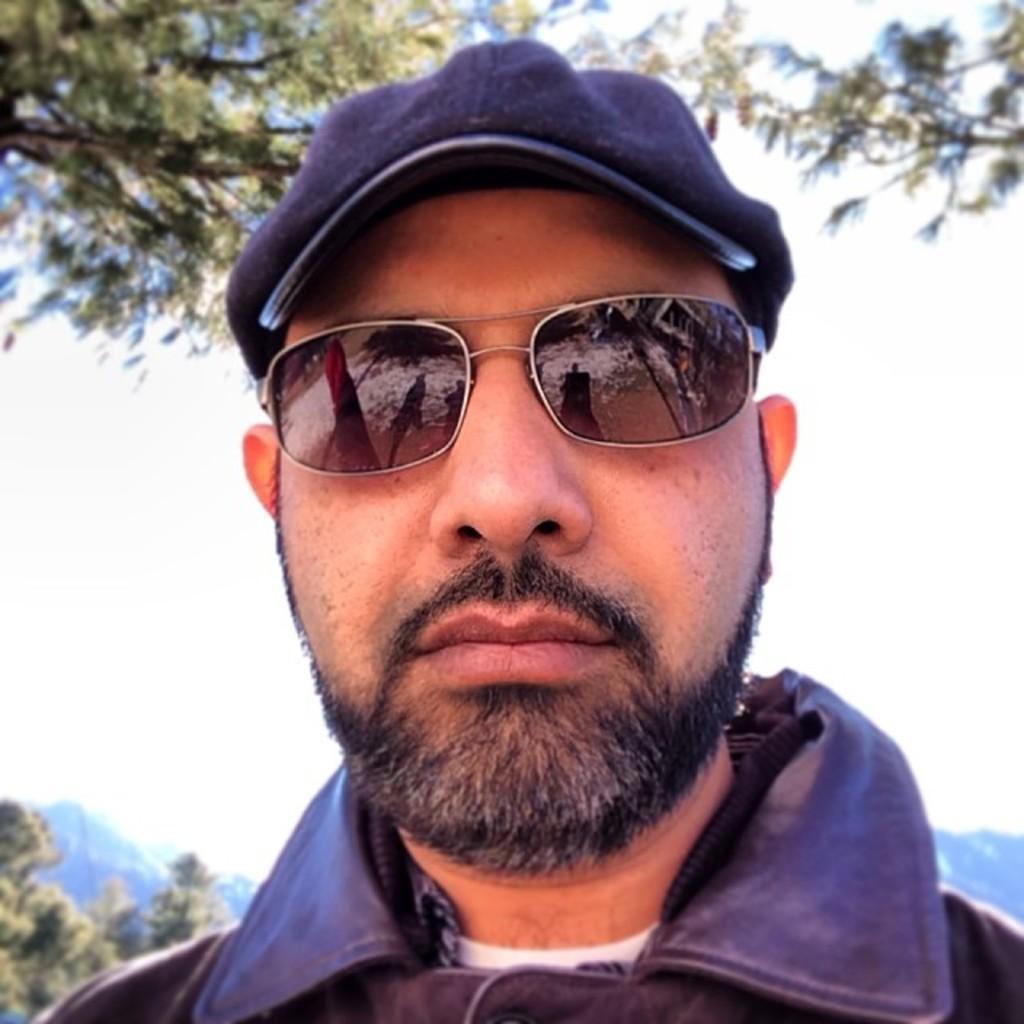What is the main subject of the picture? The main subject of the picture is a man. Can you describe what the man is wearing? The man is wearing a cap, shoes, and clothes. What can be seen in the background of the picture? There are trees, mountains, and the sky visible in the background of the picture. What type of worm can be seen crawling on the man's hands in the image? There is no worm present in the image, and the man's hands are not visible. Is the man's father also present in the image? The provided facts do not mention the presence of the man's father, so we cannot determine if he is present in the image. 